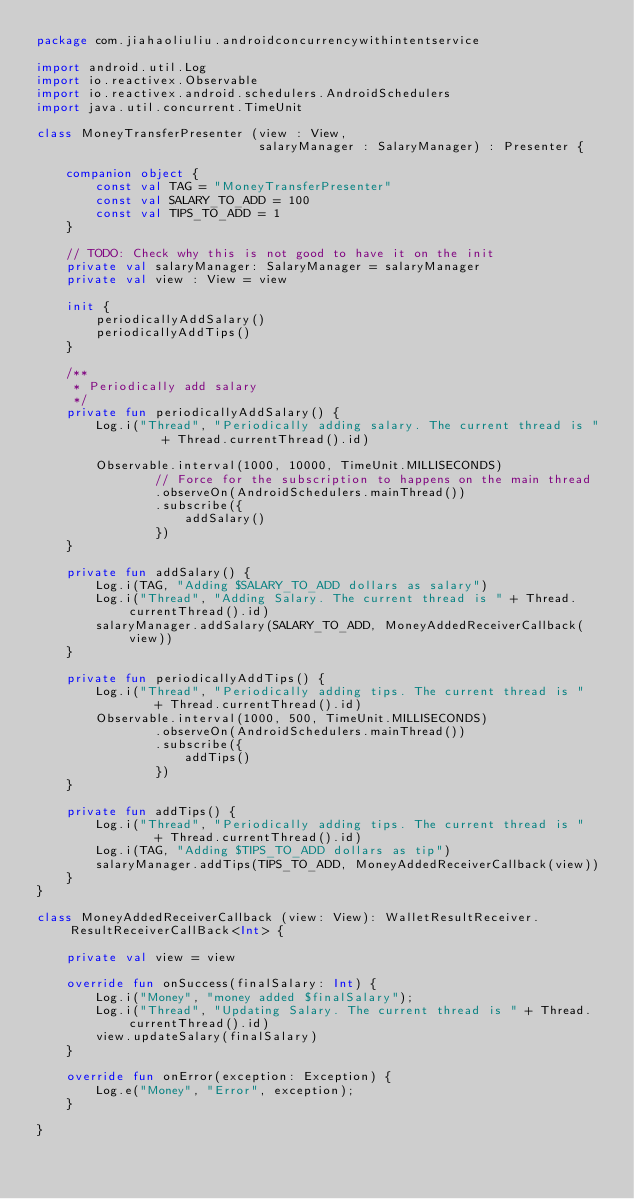<code> <loc_0><loc_0><loc_500><loc_500><_Kotlin_>package com.jiahaoliuliu.androidconcurrencywithintentservice

import android.util.Log
import io.reactivex.Observable
import io.reactivex.android.schedulers.AndroidSchedulers
import java.util.concurrent.TimeUnit

class MoneyTransferPresenter (view : View,
                              salaryManager : SalaryManager) : Presenter {

    companion object {
        const val TAG = "MoneyTransferPresenter"
        const val SALARY_TO_ADD = 100
        const val TIPS_TO_ADD = 1
    }

    // TODO: Check why this is not good to have it on the init
    private val salaryManager: SalaryManager = salaryManager
    private val view : View = view

    init {
        periodicallyAddSalary()
        periodicallyAddTips()
    }

    /**
     * Periodically add salary
     */
    private fun periodicallyAddSalary() {
        Log.i("Thread", "Periodically adding salary. The current thread is "
                 + Thread.currentThread().id)

        Observable.interval(1000, 10000, TimeUnit.MILLISECONDS)
                // Force for the subscription to happens on the main thread
                .observeOn(AndroidSchedulers.mainThread())
                .subscribe({
                    addSalary()
                })
    }

    private fun addSalary() {
        Log.i(TAG, "Adding $SALARY_TO_ADD dollars as salary")
        Log.i("Thread", "Adding Salary. The current thread is " + Thread.currentThread().id)
        salaryManager.addSalary(SALARY_TO_ADD, MoneyAddedReceiverCallback(view))
    }

    private fun periodicallyAddTips() {
        Log.i("Thread", "Periodically adding tips. The current thread is "
                + Thread.currentThread().id)
        Observable.interval(1000, 500, TimeUnit.MILLISECONDS)
                .observeOn(AndroidSchedulers.mainThread())
                .subscribe({
                    addTips()
                })
    }

    private fun addTips() {
        Log.i("Thread", "Periodically adding tips. The current thread is "
                + Thread.currentThread().id)
        Log.i(TAG, "Adding $TIPS_TO_ADD dollars as tip")
        salaryManager.addTips(TIPS_TO_ADD, MoneyAddedReceiverCallback(view))
    }
}

class MoneyAddedReceiverCallback (view: View): WalletResultReceiver.ResultReceiverCallBack<Int> {

    private val view = view

    override fun onSuccess(finalSalary: Int) {
        Log.i("Money", "money added $finalSalary");
        Log.i("Thread", "Updating Salary. The current thread is " + Thread.currentThread().id)
        view.updateSalary(finalSalary)
    }

    override fun onError(exception: Exception) {
        Log.e("Money", "Error", exception);
    }

}</code> 